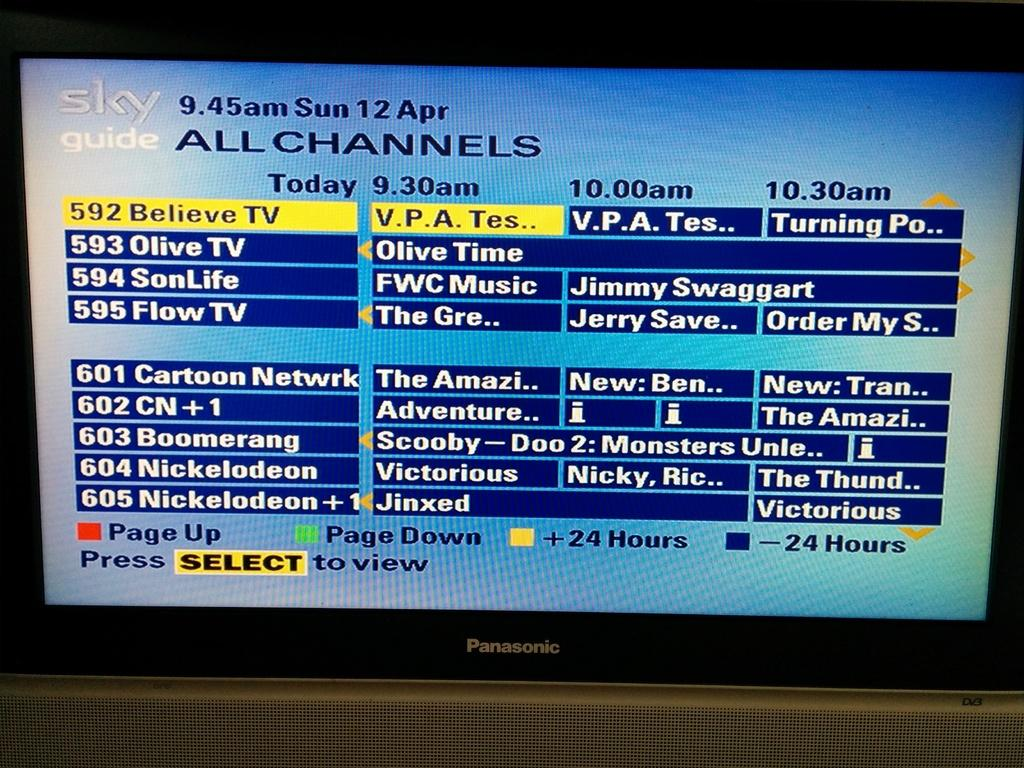<image>
Render a clear and concise summary of the photo. A Panasonic TV that is showing the sky guide of all channels 